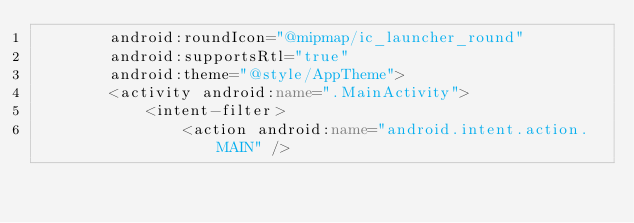<code> <loc_0><loc_0><loc_500><loc_500><_XML_>        android:roundIcon="@mipmap/ic_launcher_round"
        android:supportsRtl="true"
        android:theme="@style/AppTheme">
        <activity android:name=".MainActivity">
            <intent-filter>
                <action android:name="android.intent.action.MAIN" />
</code> 